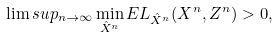Convert formula to latex. <formula><loc_0><loc_0><loc_500><loc_500>\lim s u p _ { n \rightarrow \infty } \min _ { \hat { X } ^ { n } } E L _ { \hat { X } ^ { n } } ( X ^ { n } , Z ^ { n } ) > 0 ,</formula> 